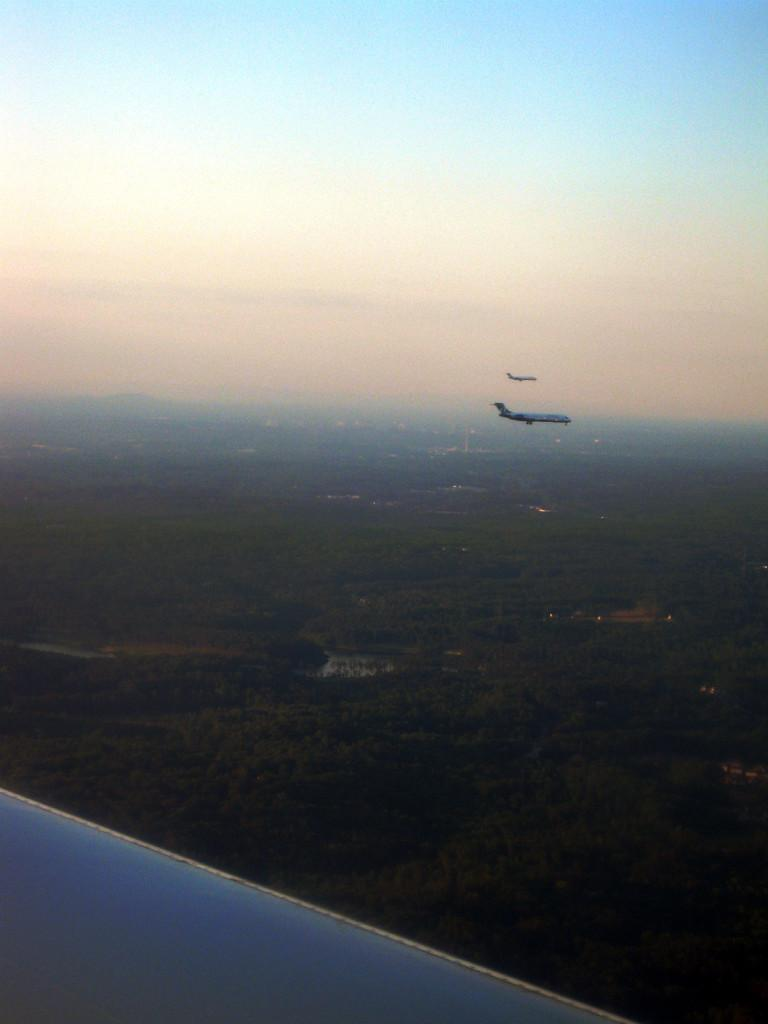What is in the sky in the image? There are aeroplanes in the sky in the image. What can be seen at the bottom of the image? There are buildings at the bottom of the image. What type of vegetation is visible in the image? Trees are visible in the image. What is visible beneath the trees and buildings? There is ground visible in the image. Where are the grapes located in the image? There are no grapes present in the image. What type of underwear is being worn by the trees in the image? There are no underwear items present in the image, as it features trees and other inanimate objects. 